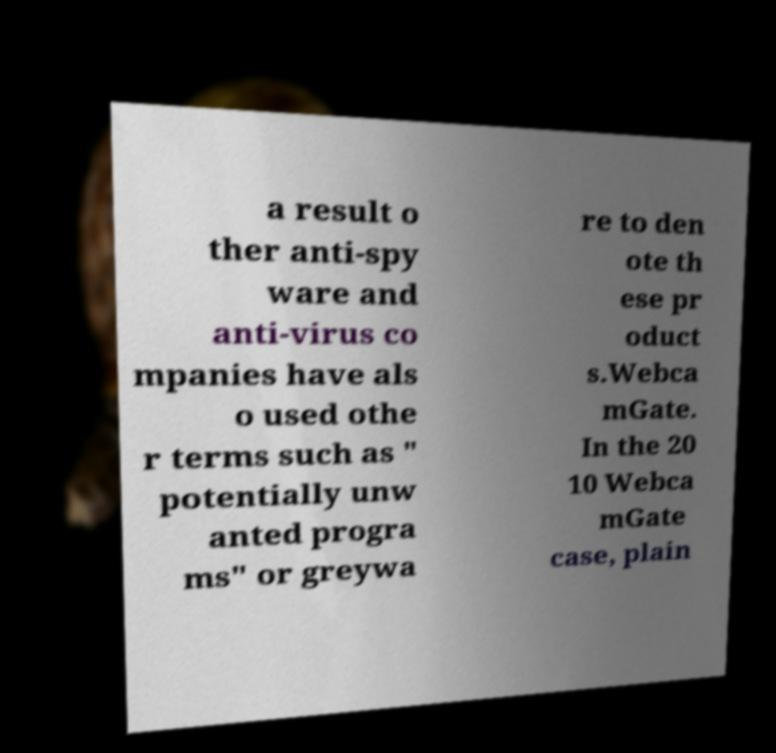I need the written content from this picture converted into text. Can you do that? a result o ther anti-spy ware and anti-virus co mpanies have als o used othe r terms such as " potentially unw anted progra ms" or greywa re to den ote th ese pr oduct s.Webca mGate. In the 20 10 Webca mGate case, plain 